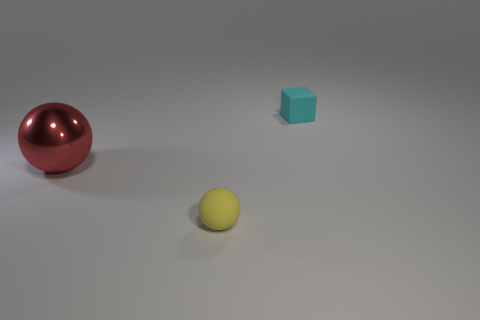Subtract all yellow spheres. How many spheres are left? 1 Subtract all spheres. How many objects are left? 1 Add 3 red metallic spheres. How many red metallic spheres are left? 4 Add 2 small brown metal blocks. How many small brown metal blocks exist? 2 Add 2 big shiny objects. How many objects exist? 5 Subtract 0 gray balls. How many objects are left? 3 Subtract 1 cubes. How many cubes are left? 0 Subtract all brown spheres. Subtract all cyan blocks. How many spheres are left? 2 Subtract all purple cubes. How many yellow spheres are left? 1 Subtract all cyan cubes. Subtract all yellow spheres. How many objects are left? 1 